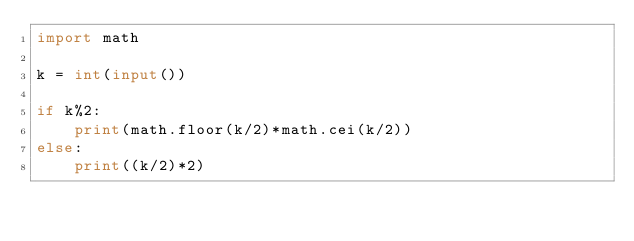<code> <loc_0><loc_0><loc_500><loc_500><_Python_>import math

k = int(input())

if k%2:
    print(math.floor(k/2)*math.cei(k/2))
else:
    print((k/2)*2)</code> 